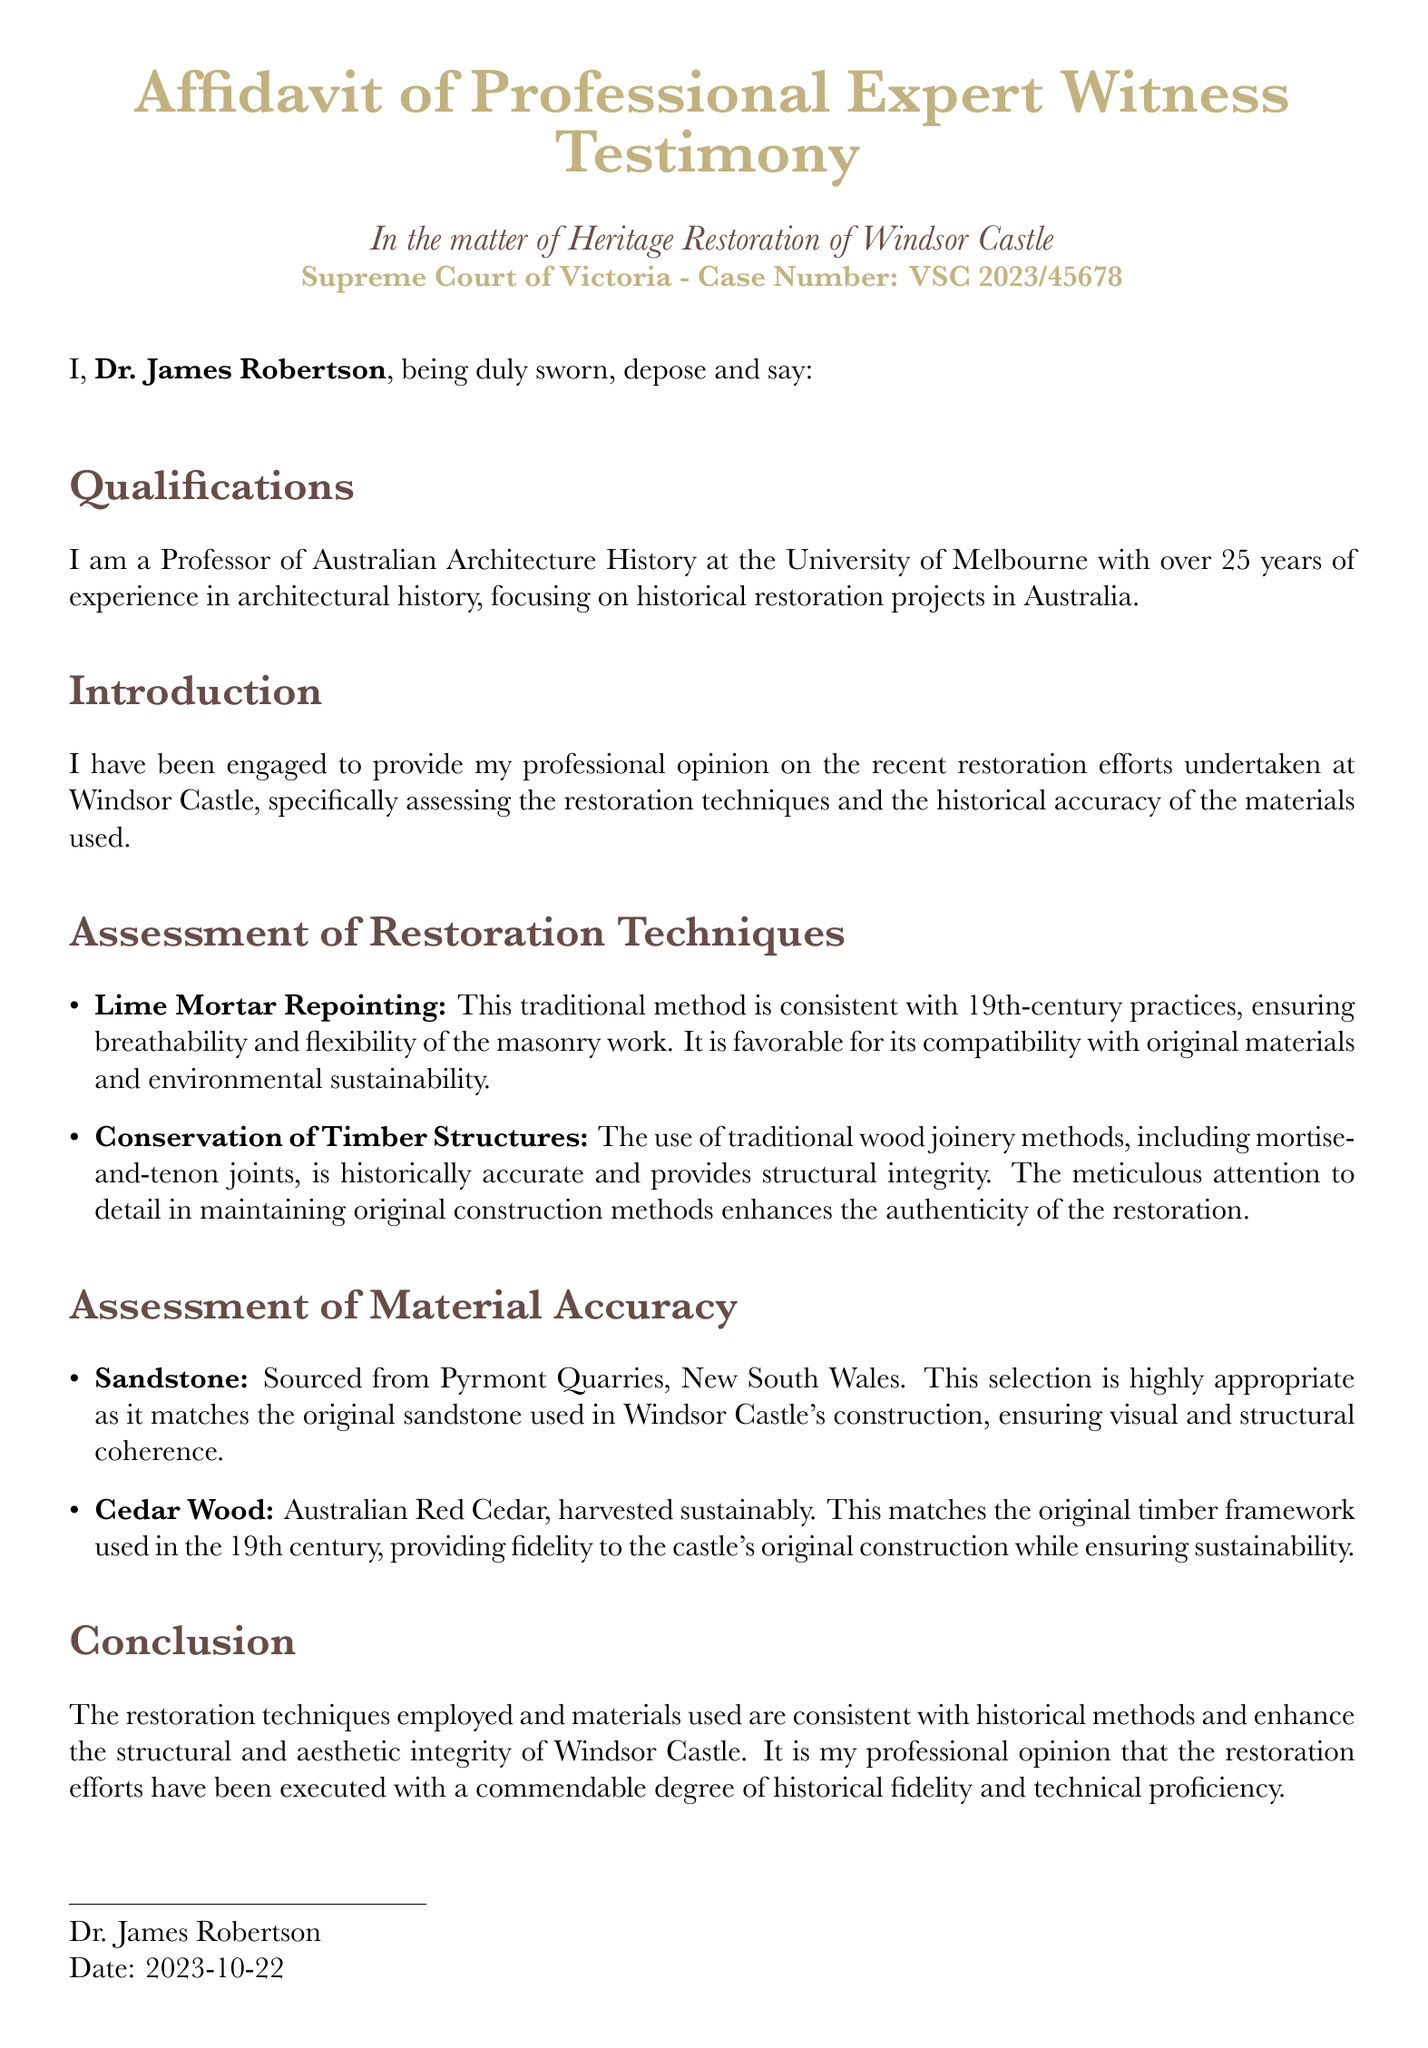What is the name of the affiant? The affiant is the person who swears to the truthfulness of the affidavit, in this case, it is Dr. James Robertson.
Answer: Dr. James Robertson What is the case number associated with this affidavit? The document specifies a case number for reference within the court system, which is VSC 2023/45678.
Answer: VSC 2023/45678 Where is the affiant employed? The document states that the affiant is employed at a specific educational institution, which is the University of Melbourne.
Answer: University of Melbourne What type of mortar was used in the restoration? The document mentions a traditional method used in the restoration which is lime mortar repointing.
Answer: Lime Mortar Repointing What type of wood was used in the restoration? The document identifies a specific type of wood that matches the original timber framework, which is Australian Red Cedar.
Answer: Australian Red Cedar What is the date of the affidavit? The document provides a specific date on which the affidavit was sworn, which is 2023-10-22.
Answer: 2023-10-22 What is the focus of Dr. James Robertson's expertise? The affidavit clearly outlines the area of expertise of the affiant, which is Australian Architecture History.
Answer: Australian Architecture History What kind of techniques does the affidavit assess? The document highlights specific techniques used in the restoration, mentioning both restoration techniques and material accuracy.
Answer: Restoration techniques and material accuracy What is the final conclusion about the restoration efforts? The affidavit provides an overall assessment of the restoration efforts, stating that they have been executed with commendable historical fidelity.
Answer: Commendable degree of historical fidelity 